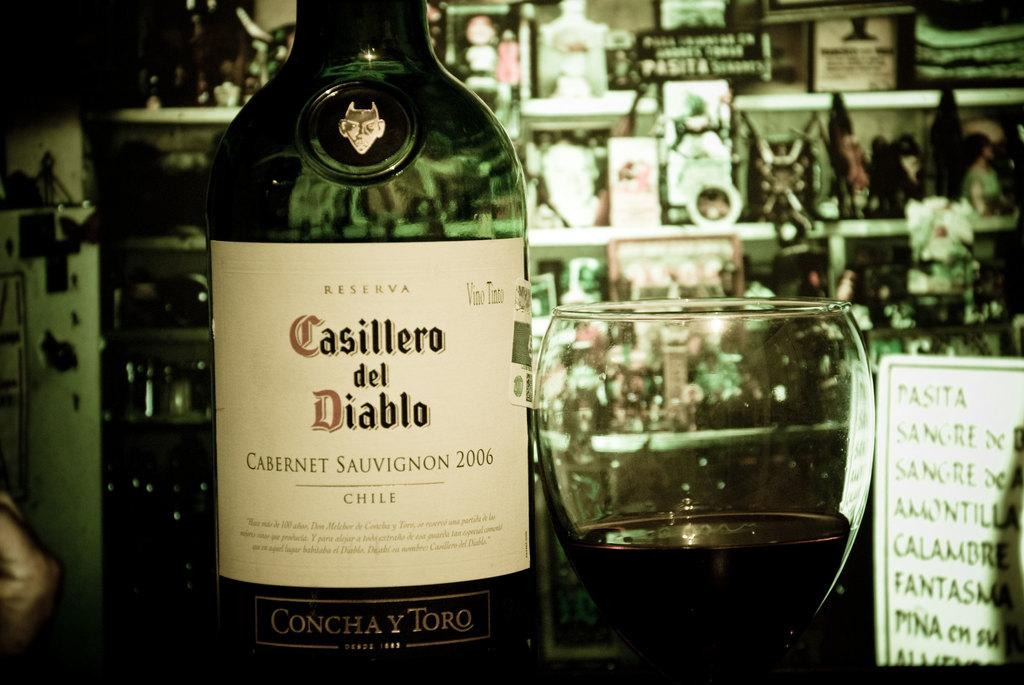<image>
Write a terse but informative summary of the picture. A bottle of red wine from Chile sits next to a half full wine glass. 